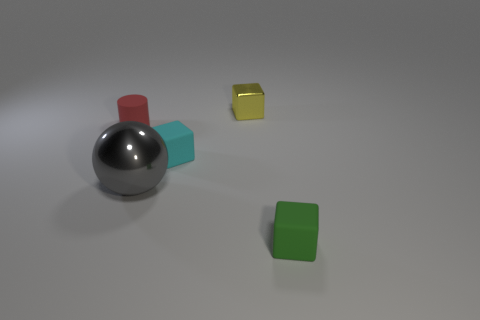Are there more yellow shiny cubes that are in front of the cyan cube than big red shiny spheres?
Offer a terse response. No. How many small red rubber things are in front of the tiny cyan rubber block?
Offer a very short reply. 0. There is a rubber cube that is on the left side of the rubber object to the right of the metal cube; is there a red cylinder to the right of it?
Make the answer very short. No. Do the rubber cylinder and the cyan thing have the same size?
Your answer should be very brief. Yes. Is the number of tiny shiny cubes left of the yellow object the same as the number of green rubber cubes that are to the right of the small cyan thing?
Offer a very short reply. No. What is the shape of the shiny thing in front of the red thing?
Your response must be concise. Sphere. What shape is the green matte thing that is the same size as the cyan block?
Make the answer very short. Cube. The tiny thing that is behind the small matte thing left of the metal object that is in front of the tiny rubber cylinder is what color?
Give a very brief answer. Yellow. Is the cyan rubber thing the same shape as the tiny yellow shiny object?
Keep it short and to the point. Yes. Are there an equal number of small yellow objects that are behind the ball and gray cylinders?
Provide a succinct answer. No. 